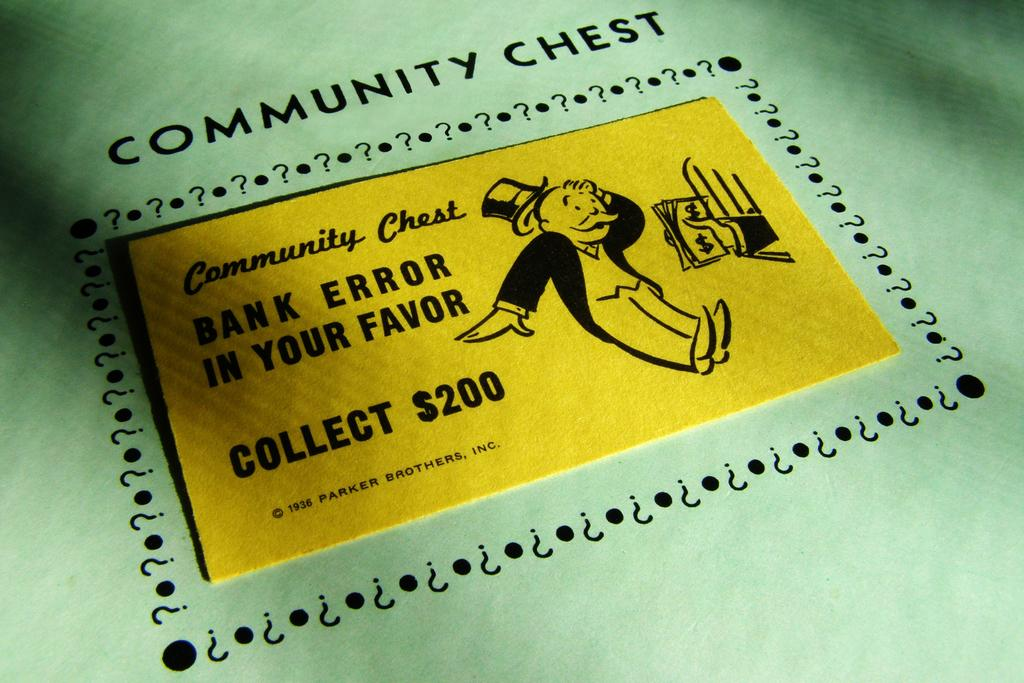What is present on the cardboard sheet in the image? There is text and cartoon images on the cardboard sheet. Can you describe the text on the cardboard sheet? Unfortunately, the specific content of the text cannot be determined from the image alone. What type of images are depicted on the cardboard sheet? The images are cartoon-style illustrations. What type of creature is shown interacting with the sponge in the image? There is no creature or sponge present in the image; it only features text and cartoon images on a cardboard sheet. 